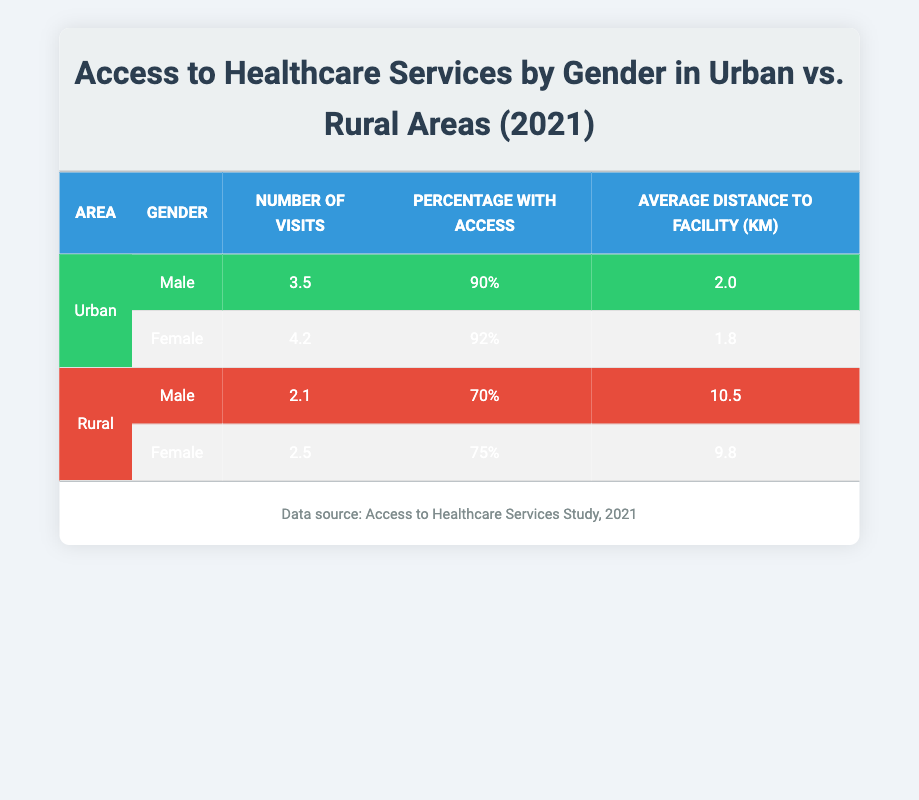What is the average distance to a healthcare facility for males in urban areas? For males in urban areas, the average distance to a facility is directly provided in the table as 2.0 km.
Answer: 2.0 km How many visits do females in rural areas make on average? The table indicates that females in rural areas have an average of 2.5 visits.
Answer: 2.5 visits Is the percentage of males with access to healthcare services higher in urban or rural areas? In urban areas, the percentage of males with access is 90%, while in rural areas, it is 70%. Thus, the percentage is higher in urban areas.
Answer: Yes What is the combined average number of visits for males and females in urban areas? The number of visits for males is 3.5 and for females is 4.2. The combined average is calculated as (3.5 + 4.2) / 2 = 3.85.
Answer: 3.85 visits What is the difference in average distance to healthcare facilities between males in rural and urban areas? Males in rural areas have an average distance of 10.5 km, while in urban areas it is 2.0 km. The difference is 10.5 - 2.0 = 8.5 km.
Answer: 8.5 km Are females more likely to have higher access percentages than males in both urban and rural areas? In urban areas, females have 92% access while males have 90%. In rural areas, females have 75% access while males have 70%. In both cases, females have higher percentages than males.
Answer: Yes What is the total number of visits for females in both urban and rural areas? The number of visits for females in urban areas is 4.2 and in rural areas is 2.5. The total is 4.2 + 2.5 = 6.7 visits.
Answer: 6.7 visits What percentage of rural males have access to healthcare services? The table shows that the percentage of rural males with access to healthcare services is 70%.
Answer: 70% 